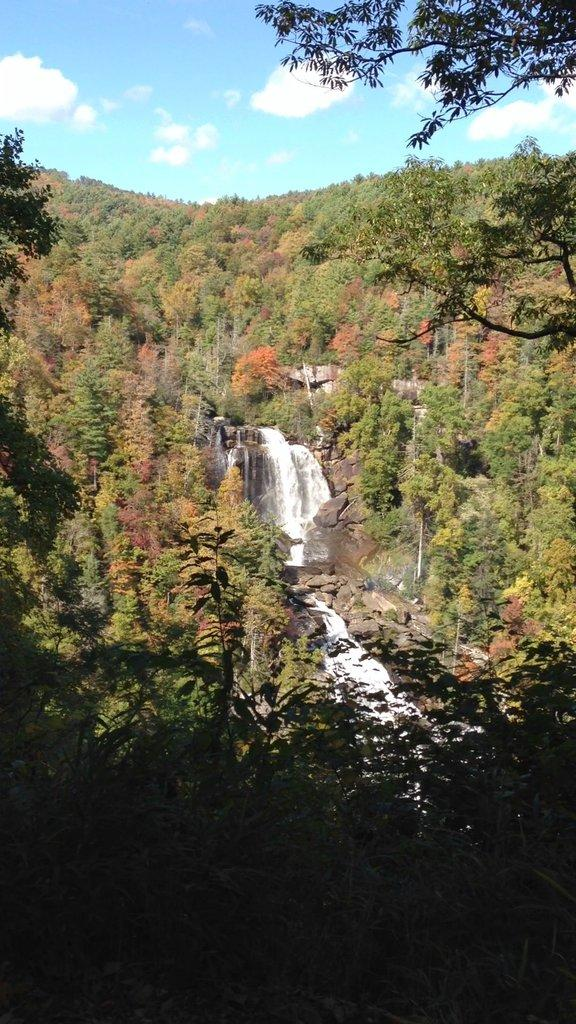What type of natural features can be seen in the image? There are trees and a waterfall in the image. What else is present in the image besides the trees and waterfall? There are rocks in the image. How would you describe the sky in the image? The sky is blue and cloudy in the image. Can you see any scissors or crayons being used in the image? No, there are no scissors or crayons present in the image. Is there any connection between the trees and the waterfall in the image? The image does not show a direct connection between the trees and the waterfall; they are simply two separate natural features in the scene. 